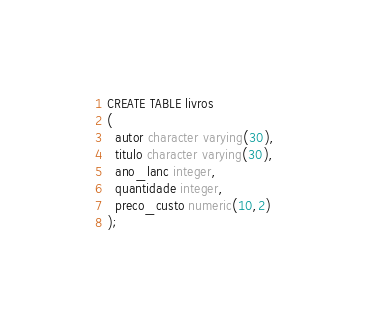<code> <loc_0><loc_0><loc_500><loc_500><_SQL_>CREATE TABLE livros
(
  autor character varying(30),
  titulo character varying(30),
  ano_lanc integer,
  quantidade integer,
  preco_custo numeric(10,2)
);</code> 